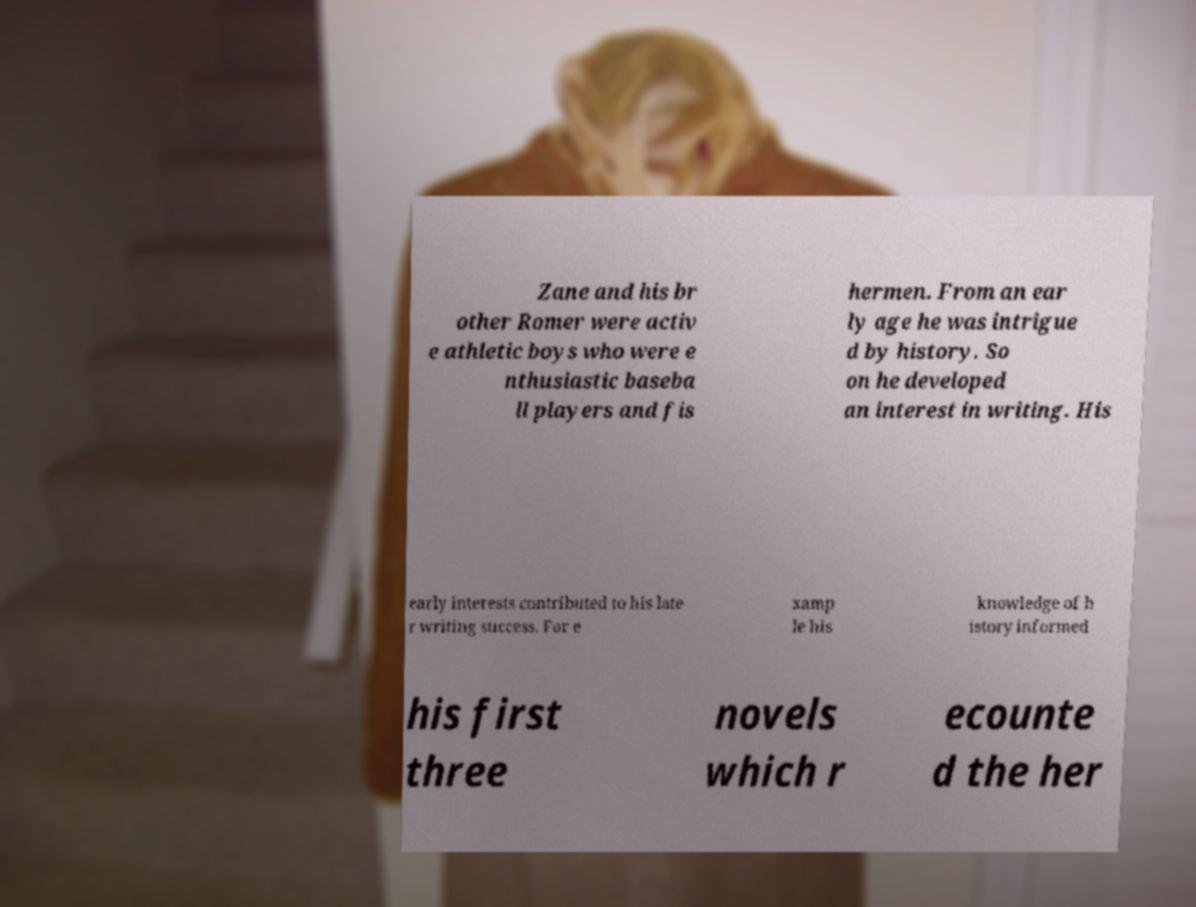Could you extract and type out the text from this image? Zane and his br other Romer were activ e athletic boys who were e nthusiastic baseba ll players and fis hermen. From an ear ly age he was intrigue d by history. So on he developed an interest in writing. His early interests contributed to his late r writing success. For e xamp le his knowledge of h istory informed his first three novels which r ecounte d the her 